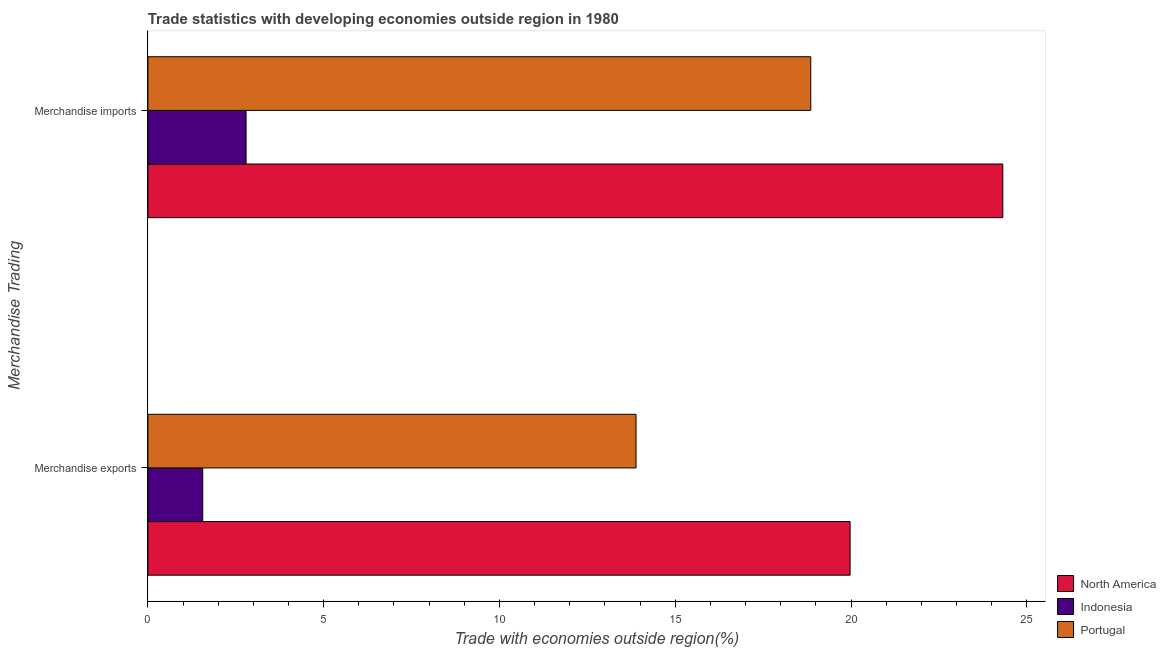Are the number of bars on each tick of the Y-axis equal?
Provide a short and direct response. Yes. What is the merchandise imports in Portugal?
Ensure brevity in your answer.  18.85. Across all countries, what is the maximum merchandise imports?
Make the answer very short. 24.32. Across all countries, what is the minimum merchandise exports?
Offer a terse response. 1.56. In which country was the merchandise exports maximum?
Keep it short and to the point. North America. What is the total merchandise imports in the graph?
Provide a short and direct response. 45.96. What is the difference between the merchandise exports in North America and that in Indonesia?
Your response must be concise. 18.41. What is the difference between the merchandise exports in Indonesia and the merchandise imports in North America?
Your answer should be compact. -22.76. What is the average merchandise exports per country?
Provide a succinct answer. 11.81. What is the difference between the merchandise exports and merchandise imports in Indonesia?
Your response must be concise. -1.23. In how many countries, is the merchandise imports greater than 8 %?
Ensure brevity in your answer.  2. What is the ratio of the merchandise imports in Portugal to that in North America?
Ensure brevity in your answer.  0.78. In how many countries, is the merchandise exports greater than the average merchandise exports taken over all countries?
Your response must be concise. 2. What does the 1st bar from the top in Merchandise imports represents?
Your answer should be compact. Portugal. How many bars are there?
Offer a terse response. 6. Are all the bars in the graph horizontal?
Provide a short and direct response. Yes. What is the difference between two consecutive major ticks on the X-axis?
Make the answer very short. 5. Does the graph contain grids?
Give a very brief answer. No. Where does the legend appear in the graph?
Offer a terse response. Bottom right. How many legend labels are there?
Offer a very short reply. 3. How are the legend labels stacked?
Provide a succinct answer. Vertical. What is the title of the graph?
Your answer should be compact. Trade statistics with developing economies outside region in 1980. Does "Curacao" appear as one of the legend labels in the graph?
Make the answer very short. No. What is the label or title of the X-axis?
Provide a succinct answer. Trade with economies outside region(%). What is the label or title of the Y-axis?
Provide a succinct answer. Merchandise Trading. What is the Trade with economies outside region(%) of North America in Merchandise exports?
Make the answer very short. 19.97. What is the Trade with economies outside region(%) of Indonesia in Merchandise exports?
Your answer should be compact. 1.56. What is the Trade with economies outside region(%) of Portugal in Merchandise exports?
Offer a very short reply. 13.88. What is the Trade with economies outside region(%) in North America in Merchandise imports?
Keep it short and to the point. 24.32. What is the Trade with economies outside region(%) of Indonesia in Merchandise imports?
Your answer should be very brief. 2.79. What is the Trade with economies outside region(%) in Portugal in Merchandise imports?
Provide a short and direct response. 18.85. Across all Merchandise Trading, what is the maximum Trade with economies outside region(%) of North America?
Your answer should be compact. 24.32. Across all Merchandise Trading, what is the maximum Trade with economies outside region(%) in Indonesia?
Provide a short and direct response. 2.79. Across all Merchandise Trading, what is the maximum Trade with economies outside region(%) of Portugal?
Keep it short and to the point. 18.85. Across all Merchandise Trading, what is the minimum Trade with economies outside region(%) in North America?
Your answer should be compact. 19.97. Across all Merchandise Trading, what is the minimum Trade with economies outside region(%) in Indonesia?
Your answer should be compact. 1.56. Across all Merchandise Trading, what is the minimum Trade with economies outside region(%) of Portugal?
Give a very brief answer. 13.88. What is the total Trade with economies outside region(%) in North America in the graph?
Your response must be concise. 44.29. What is the total Trade with economies outside region(%) of Indonesia in the graph?
Offer a terse response. 4.35. What is the total Trade with economies outside region(%) in Portugal in the graph?
Offer a terse response. 32.74. What is the difference between the Trade with economies outside region(%) of North America in Merchandise exports and that in Merchandise imports?
Offer a very short reply. -4.34. What is the difference between the Trade with economies outside region(%) of Indonesia in Merchandise exports and that in Merchandise imports?
Offer a terse response. -1.23. What is the difference between the Trade with economies outside region(%) in Portugal in Merchandise exports and that in Merchandise imports?
Your answer should be very brief. -4.97. What is the difference between the Trade with economies outside region(%) of North America in Merchandise exports and the Trade with economies outside region(%) of Indonesia in Merchandise imports?
Your response must be concise. 17.18. What is the difference between the Trade with economies outside region(%) of North America in Merchandise exports and the Trade with economies outside region(%) of Portugal in Merchandise imports?
Give a very brief answer. 1.12. What is the difference between the Trade with economies outside region(%) in Indonesia in Merchandise exports and the Trade with economies outside region(%) in Portugal in Merchandise imports?
Your response must be concise. -17.29. What is the average Trade with economies outside region(%) of North America per Merchandise Trading?
Make the answer very short. 22.14. What is the average Trade with economies outside region(%) of Indonesia per Merchandise Trading?
Provide a short and direct response. 2.18. What is the average Trade with economies outside region(%) in Portugal per Merchandise Trading?
Your answer should be very brief. 16.37. What is the difference between the Trade with economies outside region(%) of North America and Trade with economies outside region(%) of Indonesia in Merchandise exports?
Your answer should be very brief. 18.41. What is the difference between the Trade with economies outside region(%) of North America and Trade with economies outside region(%) of Portugal in Merchandise exports?
Your answer should be compact. 6.09. What is the difference between the Trade with economies outside region(%) of Indonesia and Trade with economies outside region(%) of Portugal in Merchandise exports?
Your answer should be very brief. -12.32. What is the difference between the Trade with economies outside region(%) of North America and Trade with economies outside region(%) of Indonesia in Merchandise imports?
Provide a short and direct response. 21.52. What is the difference between the Trade with economies outside region(%) in North America and Trade with economies outside region(%) in Portugal in Merchandise imports?
Give a very brief answer. 5.46. What is the difference between the Trade with economies outside region(%) in Indonesia and Trade with economies outside region(%) in Portugal in Merchandise imports?
Make the answer very short. -16.06. What is the ratio of the Trade with economies outside region(%) of North America in Merchandise exports to that in Merchandise imports?
Offer a terse response. 0.82. What is the ratio of the Trade with economies outside region(%) in Indonesia in Merchandise exports to that in Merchandise imports?
Keep it short and to the point. 0.56. What is the ratio of the Trade with economies outside region(%) in Portugal in Merchandise exports to that in Merchandise imports?
Keep it short and to the point. 0.74. What is the difference between the highest and the second highest Trade with economies outside region(%) in North America?
Your answer should be very brief. 4.34. What is the difference between the highest and the second highest Trade with economies outside region(%) of Indonesia?
Give a very brief answer. 1.23. What is the difference between the highest and the second highest Trade with economies outside region(%) of Portugal?
Give a very brief answer. 4.97. What is the difference between the highest and the lowest Trade with economies outside region(%) of North America?
Offer a terse response. 4.34. What is the difference between the highest and the lowest Trade with economies outside region(%) of Indonesia?
Your answer should be compact. 1.23. What is the difference between the highest and the lowest Trade with economies outside region(%) in Portugal?
Your response must be concise. 4.97. 